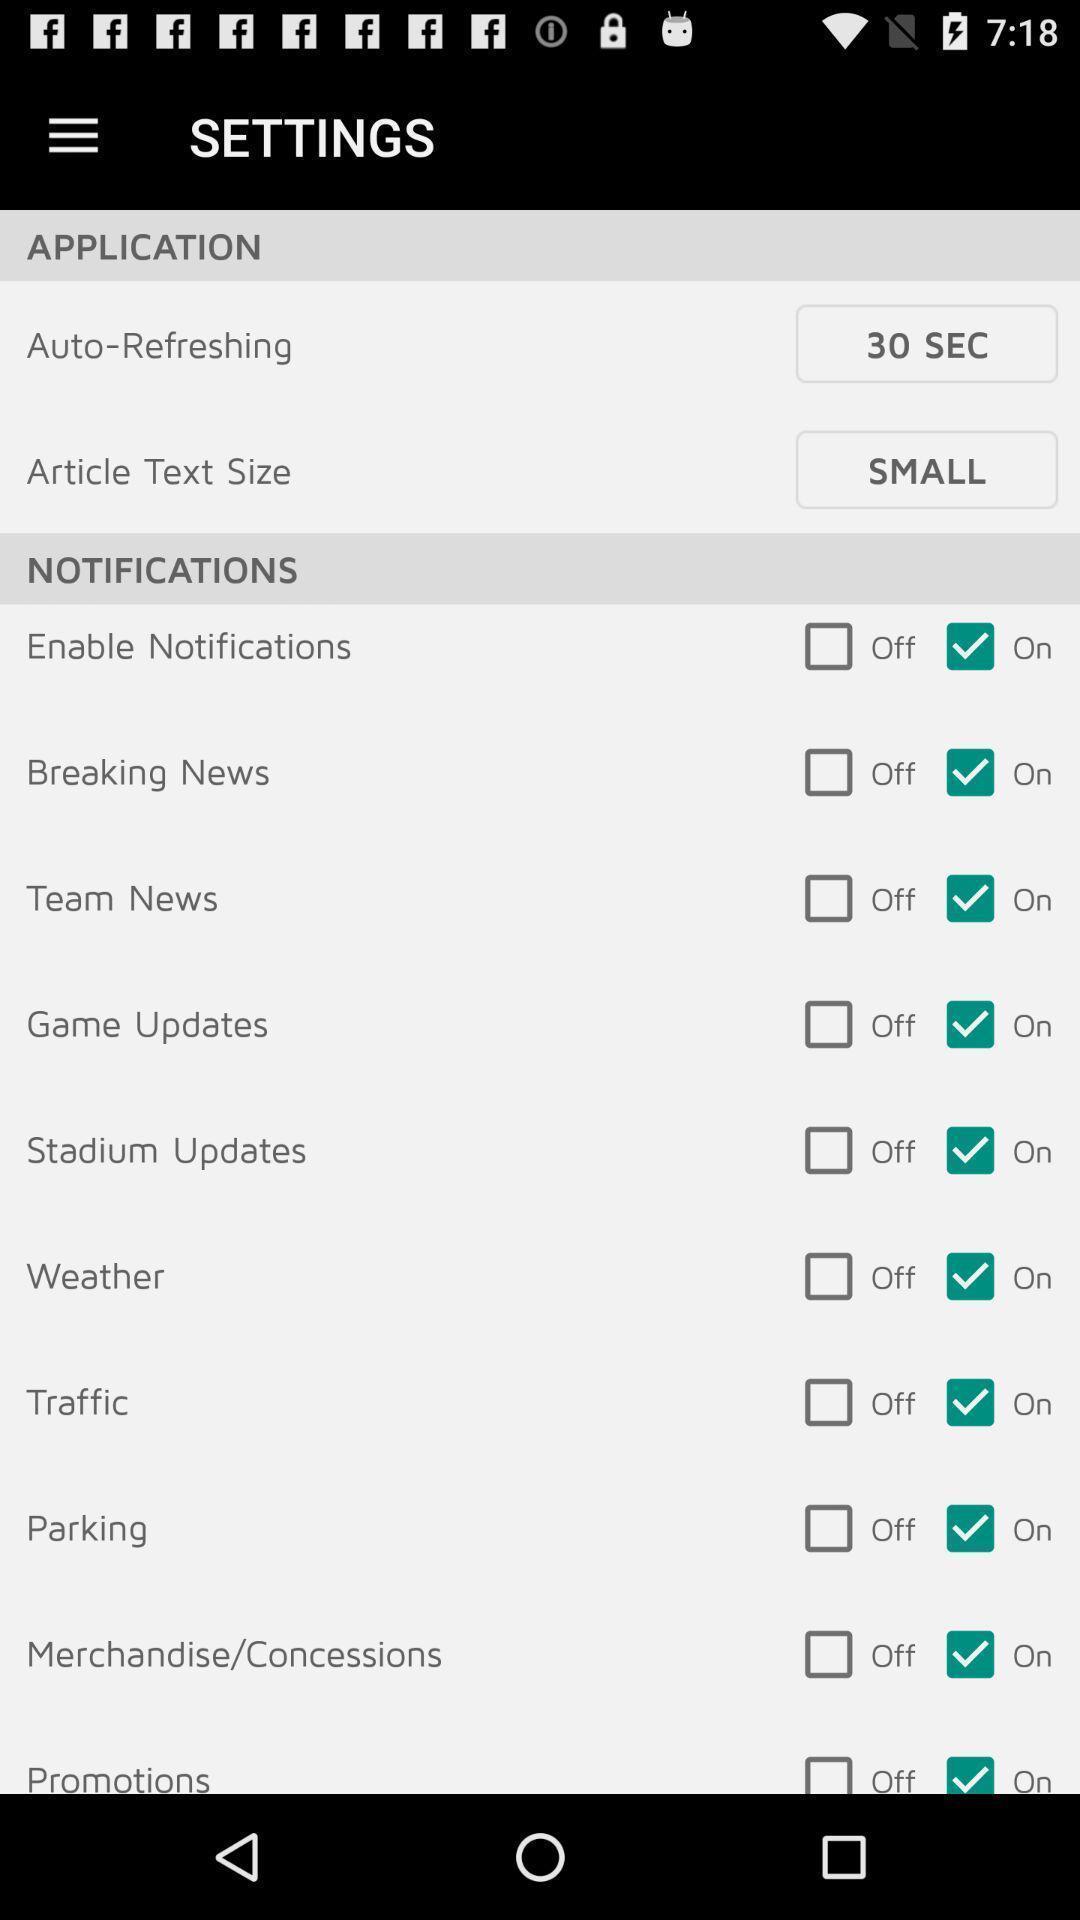Summarize the information in this screenshot. Settings page with various options. 